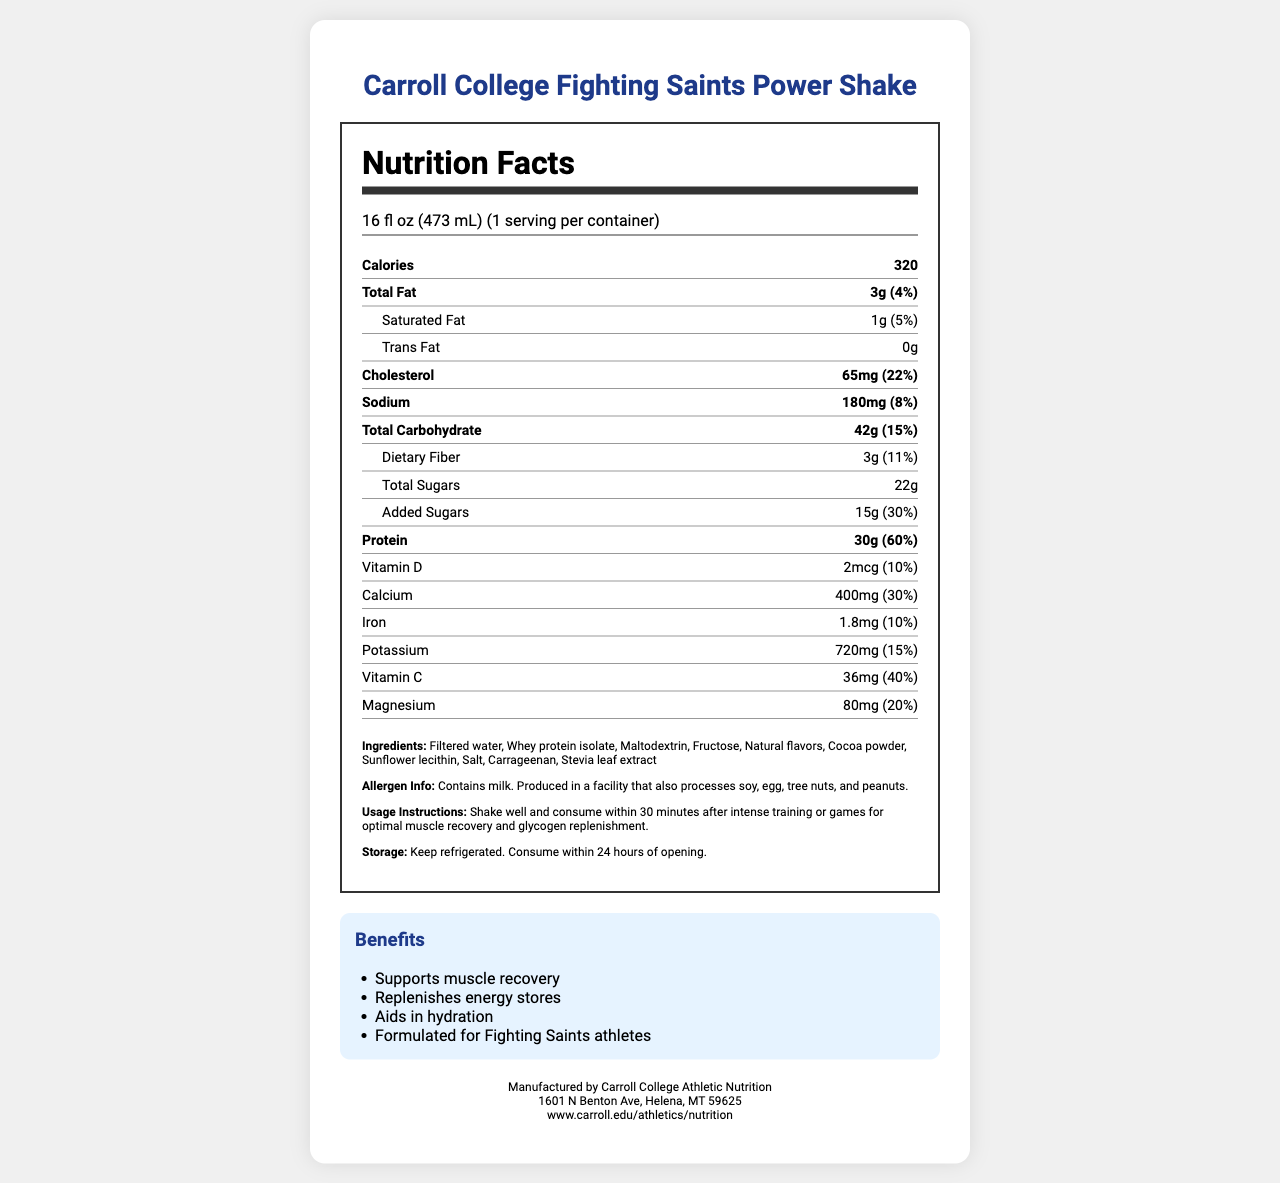what is the serving size of the Carroll College Fighting Saints Power Shake? The serving size is clearly mentioned at the top of the nutrition facts as 16 fl oz (473 mL).
Answer: 16 fl oz (473 mL) how many calories are in one serving of the Power Shake? The document states that there are 320 calories in one serving.
Answer: 320 what is the protein content per serving? The protein content per serving is stated to be 30g.
Answer: 30g what are the primary ingredients of the Power Shake? The ingredients list in the document describes these as the primary ingredients.
Answer: Filtered water, Whey protein isolate, Maltodextrin, Fructose, Natural flavors, Cocoa powder, Sunflower lecithin, Salt, Carrageenan, Stevia leaf extract how much calcium does one serving of the shake provide? The document shows that one serving provides 400mg of calcium, which is 30% of the daily value.
Answer: 400mg (30% DV) what are the known allergens in the Power Shake? The allergen information section specifies these allergens.
Answer: Contains milk. Produced in a facility that also processes soy, egg, tree nuts, and peanuts. how much sugar is added to the Power Shake? The document clearly indicates that 15g of the total sugar is added, contributing 30% to the daily value.
Answer: 15g (30% DV) what are some of the benefits of consuming the Power Shake? The benefits listed in the document include these four points.
Answer: Supports muscle recovery, Replenishes energy stores, Aids in hydration, Formulated for Fighting Saints athletes how much vitamin C is present in one serving of the Power Shake? The document mentions that there are 36mg of vitamin C per serving which is 40% of the daily value.
Answer: 36mg (40% DV) how should the Power Shake be stored? The storage instructions in the document specify this handling.
Answer: Keep refrigerated. Consume within 24 hours of opening. what is the total carbohydrate content in one serving of the Power Shake? The total carbohydrate content per serving is 42g, which is 15% of the daily value.
Answer: 42g (15% DV) when should the Power Shake be consumed for optimal benefits? According to the usage instructions, the shake should be consumed within 30 minutes after training or games.
Answer: Within 30 minutes after intense training or games which of the following nutrients is provided in the highest percentage of the daily value? A. Protein B. Vitamin D C. Iron D. Calcium Protein is provided at 60% of the daily value, which is the highest among the listed nutrients.
Answer: A. Protein which vitamin is present in the Power Shake at 10% of the daily value? A. Vitamin A B. Vitamin C C. Vitamin D D. Vitamin E The document specifies that Vitamin D is present at 10% of the daily value.
Answer: C. Vitamin D does the Power Shake contain trans fat? The document states that there is 0g of trans fat in the Power Shake.
Answer: No describe the main idea of the Carroll College Fighting Saints Power Shake nutrition label. The nutrition facts label thoroughly lists nutritional values, ingredients, and other relevant details related to the product.
Answer: The document provides detailed nutritional information about the Carroll College Fighting Saints Power Shake, including its serving size, calorie content, macronutrients, vitamins, and minerals. It also lists the ingredients, allergen info, usage instructions, storage guidelines, and bears a section on the benefits of the shake. what is the exact amount of magnesium per serving? The document states that each serving contains 80mg of magnesium which is 20% of the daily value.
Answer: 80mg (20% DV) how many servings are there per container of the Power Shake? The nutrition label indicates that there is one serving per container.
Answer: 1 how much saturated fat does one serving of the Power Shake contain? According to the document, one serving contains 1g of saturated fat which is 5% of the daily value.
Answer: 1g (5% DV) which of the following is not listed as an ingredient in the Power Shake? A. Stevia leaf extract B. Cocoa powder C. Wheat flour D. Sunflower lecithin Wheat flour is not listed among the ingredients in the document.
Answer: C. Wheat flour what is the address of the manufacturer of the Power Shake? The address section at the bottom of the document provides this detail.
Answer: 1601 N Benton Ave, Helena, MT 59625 how much dietary fiber is present per serving? The document mentions that each serving contains 3g of dietary fiber, which is 11% of the daily value.
Answer: 3g (11% DV) how much iron is in one serving of the Power Shake? The iron content listed in the document is 1.8mg per serving, which is 10% of the daily value.
Answer: 1.8mg (10% DV) does the document specify the exact amount of maltodextrin in the Power Shake? The document lists maltodextrin as an ingredient but does not specify the exact amount present.
Answer: Not enough information 